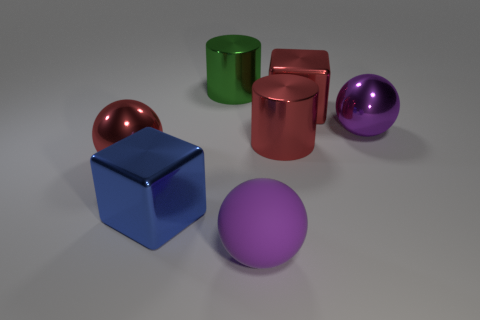Subtract all big matte balls. How many balls are left? 2 Add 2 rubber balls. How many objects exist? 9 Subtract all red balls. How many balls are left? 2 Subtract 1 cylinders. How many cylinders are left? 1 Subtract all big red metal spheres. Subtract all matte balls. How many objects are left? 5 Add 2 purple matte spheres. How many purple matte spheres are left? 3 Add 5 purple balls. How many purple balls exist? 7 Subtract 0 gray spheres. How many objects are left? 7 Subtract all cylinders. How many objects are left? 5 Subtract all purple cylinders. Subtract all purple blocks. How many cylinders are left? 2 